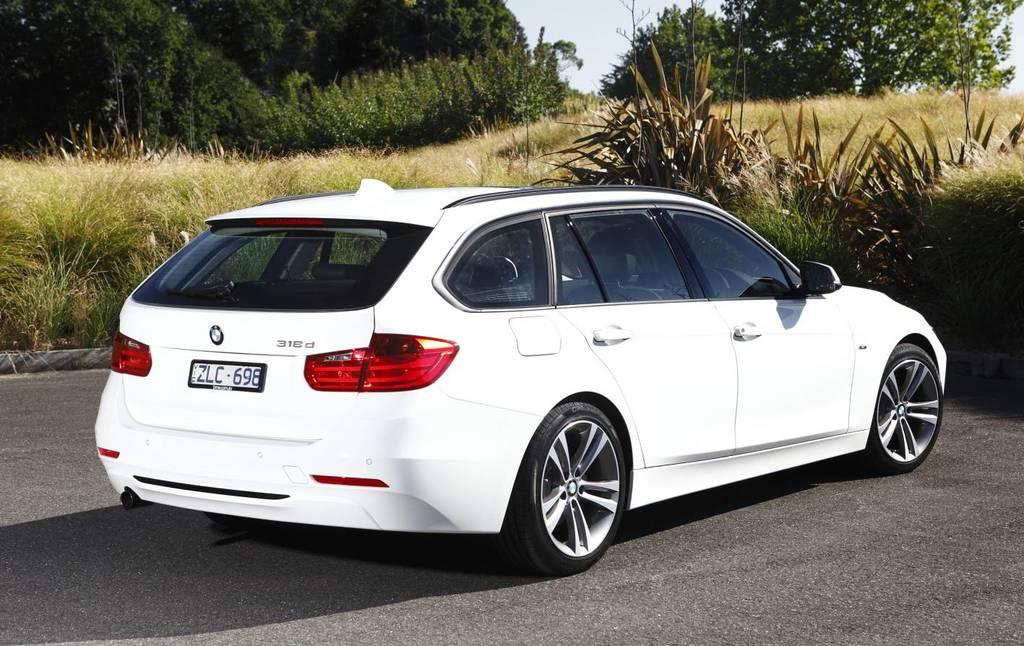<image>
Share a concise interpretation of the image provided. A white BMW 318d has a European license plate. 